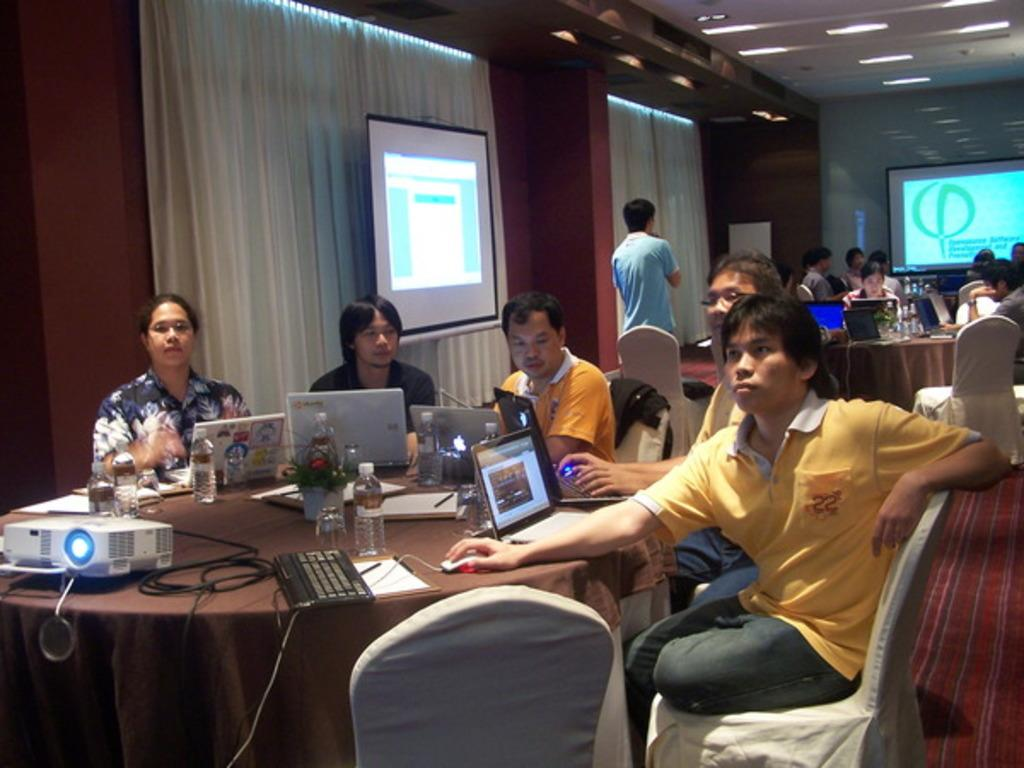What are the people in the image doing? The people are sitting around a table and working with their laptops. What is in the middle of the table? There is a projected image in the middle of the table. Can you describe the surroundings in the image? There is a curtain in the image. What type of jam is being served at the table in the image? There is no jam present in the image; the people are working with their laptops and there is a projected image in the middle of the table. 